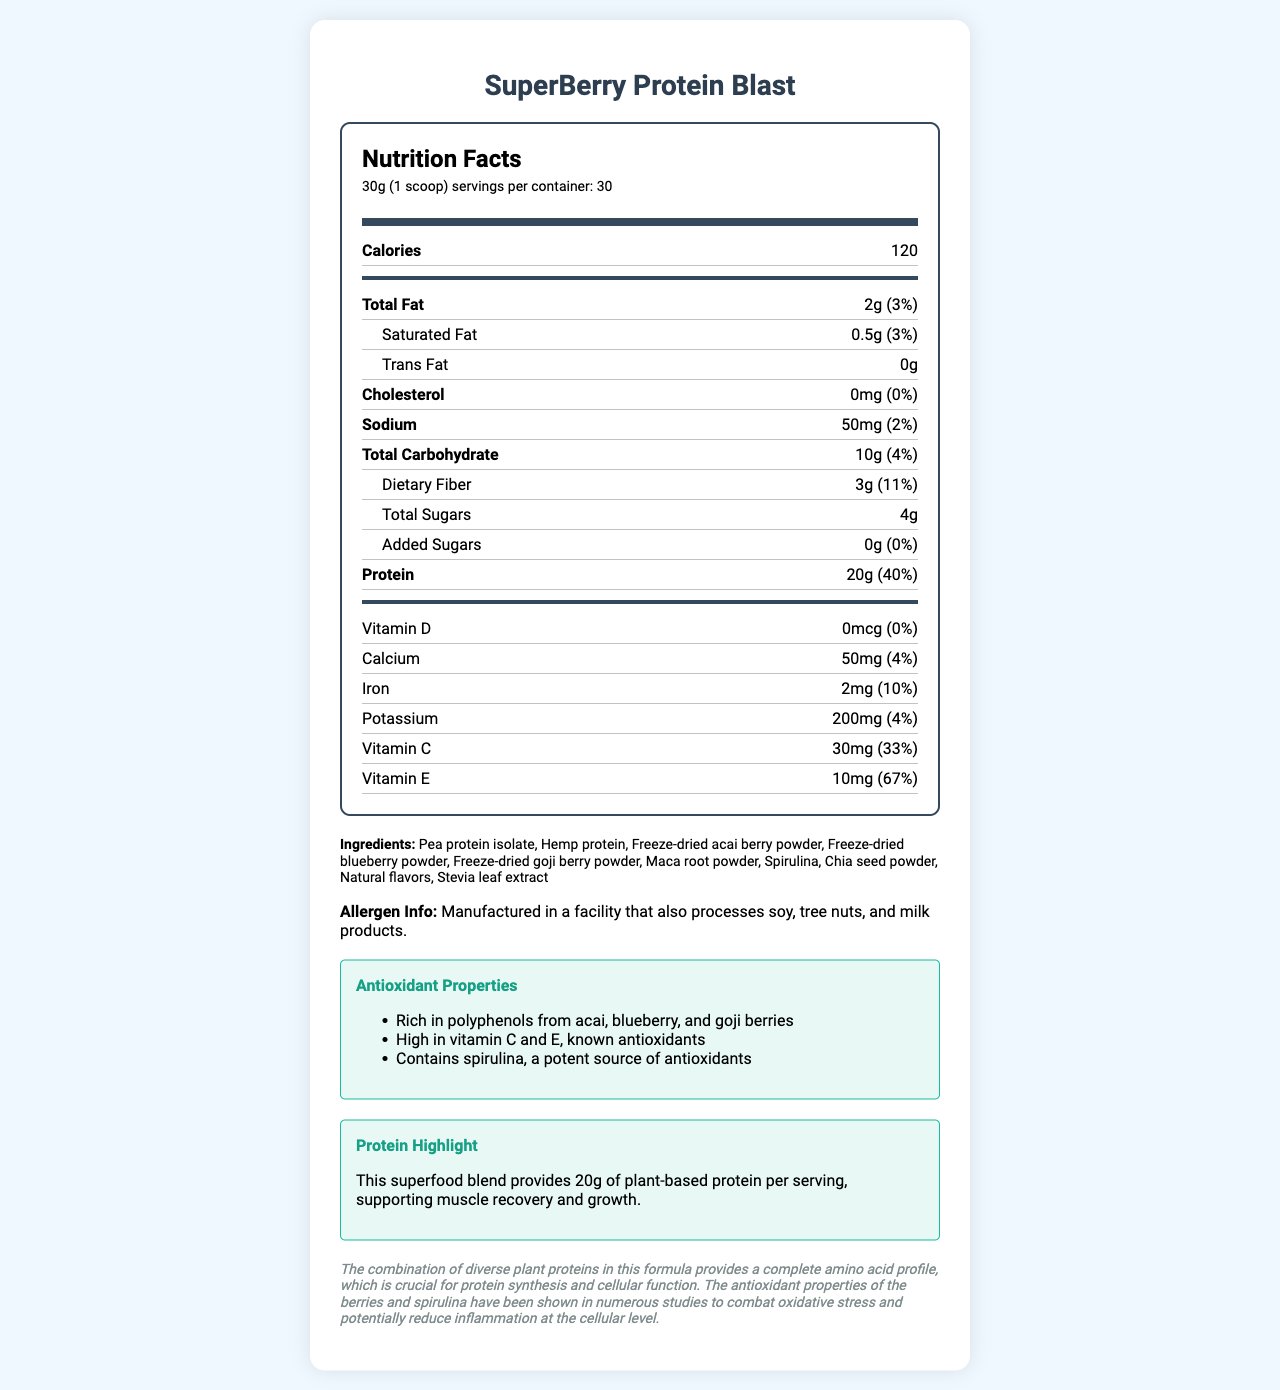What is the serving size of the SuperBerry Protein Blast? The serving size is clearly mentioned as "30g (1 scoop)" in the document.
Answer: 30g (1 scoop) How many calories does one serving of the SuperBerry Protein Blast contain? The document lists the calories per serving as 120.
Answer: 120 What percent of the daily value is the protein content in one serving? The protein content per serving is 20g, which is 40% of the daily value.
Answer: 40% Name three ingredients mentioned in the SuperBerry Protein Blast. The ingredients listed include Pea protein isolate, Hemp protein, and Freeze-dried acai berry powder among others.
Answer: Pea protein isolate, Hemp protein, Freeze-dried acai berry powder How much Vitamin C is in one serving of SuperBerry Protein Blast? Each serving contains 30mg of Vitamin C, accounting for 33% of the daily value.
Answer: 30mg Which nutrient has the highest daily value percentage per serving? A. Calcium B. Iron C. Vitamin E D. Potassium Vitamin E has 67% of the daily value per serving, which is the highest among the listed nutrients.
Answer: C. Vitamin E How many grams of dietary fiber are in a single serving? A. 2g B. 3g C. 4g D. 5g The document specifies that each serving contains 3g of dietary fiber.
Answer: B. 3g Is there any cholesterol in the SuperBerry Protein Blast? The cholesterol content is listed as 0mg with a daily value percentage of 0%.
Answer: No What are some of the antioxidant properties of the SuperBerry Protein Blast? The document details that the product is rich in polyphenols from acai, blueberry, and goji berries, high in vitamin C and E, and contains spirulina, a potent source of antioxidants.
Answer: Rich in polyphenols from acai, blueberry, and goji berries; High in vitamin C and E; Contains spirulina Does the product contain any added sugars? The document indicates that the product contains 0g of added sugars.
Answer: No Summarize the main points of the SuperBerry Protein Blast Nutrition Facts Label. The document provides detailed nutritional information, ingredient list, and health-related highlights of the SuperBerry Protein Blast, focusing on its high protein content and antioxidant properties.
Answer: The SuperBerry Protein Blast is a superfood smoothie powder with a serving size of 30g (1 scoop) and 30 servings per container. Each serving provides 120 calories, 2g of fat, 10g of carbohydrates including 3g dietary fiber and 4g sugars, and 20g of protein, among other nutrients. It also highlights its antioxidant properties due to high contents of vitamins C and E, polyphenols from various berries, and spirulina. The product does not contain cholesterol or added sugars and provides substantial plant-based protein. Can the document provide information about the price of the SuperBerry Protein Blast? The document does not include any pricing information about the product.
Answer: Not enough information What facility-related allergen information is provided? The allergen information mentioned notes that the product is manufactured in a facility that processes soy, tree nuts, and milk products.
Answer: Manufactured in a facility that also processes soy, tree nuts, and milk products. 